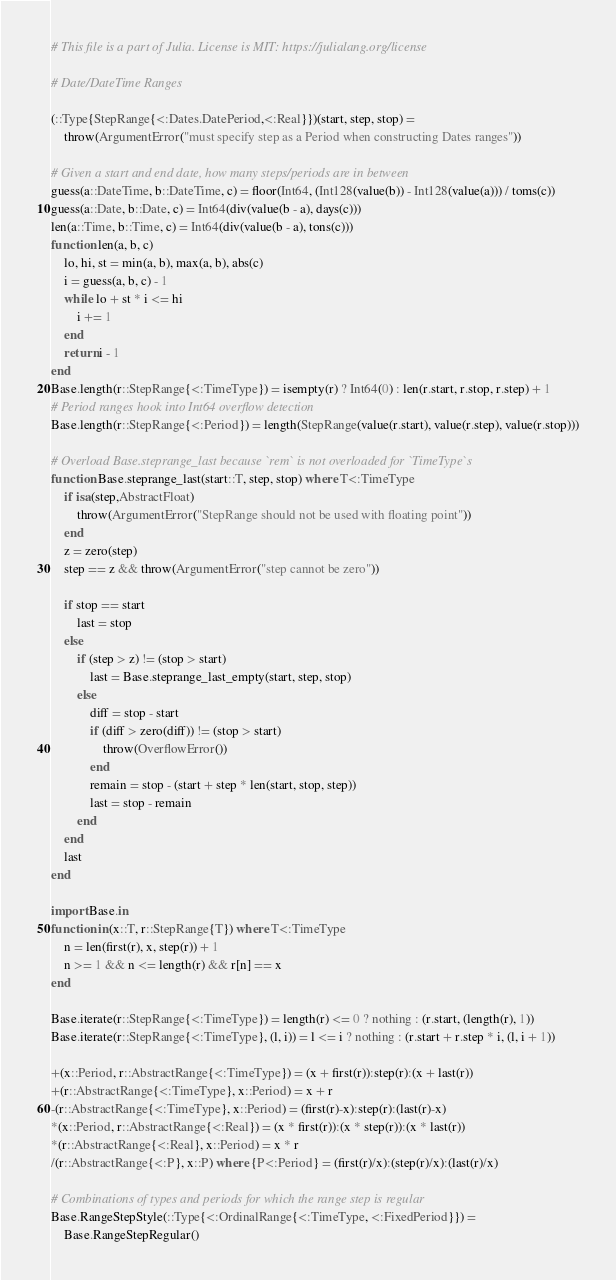<code> <loc_0><loc_0><loc_500><loc_500><_Julia_># This file is a part of Julia. License is MIT: https://julialang.org/license

# Date/DateTime Ranges

(::Type{StepRange{<:Dates.DatePeriod,<:Real}})(start, step, stop) =
    throw(ArgumentError("must specify step as a Period when constructing Dates ranges"))

# Given a start and end date, how many steps/periods are in between
guess(a::DateTime, b::DateTime, c) = floor(Int64, (Int128(value(b)) - Int128(value(a))) / toms(c))
guess(a::Date, b::Date, c) = Int64(div(value(b - a), days(c)))
len(a::Time, b::Time, c) = Int64(div(value(b - a), tons(c)))
function len(a, b, c)
    lo, hi, st = min(a, b), max(a, b), abs(c)
    i = guess(a, b, c) - 1
    while lo + st * i <= hi
        i += 1
    end
    return i - 1
end
Base.length(r::StepRange{<:TimeType}) = isempty(r) ? Int64(0) : len(r.start, r.stop, r.step) + 1
# Period ranges hook into Int64 overflow detection
Base.length(r::StepRange{<:Period}) = length(StepRange(value(r.start), value(r.step), value(r.stop)))

# Overload Base.steprange_last because `rem` is not overloaded for `TimeType`s
function Base.steprange_last(start::T, step, stop) where T<:TimeType
    if isa(step,AbstractFloat)
        throw(ArgumentError("StepRange should not be used with floating point"))
    end
    z = zero(step)
    step == z && throw(ArgumentError("step cannot be zero"))

    if stop == start
        last = stop
    else
        if (step > z) != (stop > start)
            last = Base.steprange_last_empty(start, step, stop)
        else
            diff = stop - start
            if (diff > zero(diff)) != (stop > start)
                throw(OverflowError())
            end
            remain = stop - (start + step * len(start, stop, step))
            last = stop - remain
        end
    end
    last
end

import Base.in
function in(x::T, r::StepRange{T}) where T<:TimeType
    n = len(first(r), x, step(r)) + 1
    n >= 1 && n <= length(r) && r[n] == x
end

Base.iterate(r::StepRange{<:TimeType}) = length(r) <= 0 ? nothing : (r.start, (length(r), 1))
Base.iterate(r::StepRange{<:TimeType}, (l, i)) = l <= i ? nothing : (r.start + r.step * i, (l, i + 1))

+(x::Period, r::AbstractRange{<:TimeType}) = (x + first(r)):step(r):(x + last(r))
+(r::AbstractRange{<:TimeType}, x::Period) = x + r
-(r::AbstractRange{<:TimeType}, x::Period) = (first(r)-x):step(r):(last(r)-x)
*(x::Period, r::AbstractRange{<:Real}) = (x * first(r)):(x * step(r)):(x * last(r))
*(r::AbstractRange{<:Real}, x::Period) = x * r
/(r::AbstractRange{<:P}, x::P) where {P<:Period} = (first(r)/x):(step(r)/x):(last(r)/x)

# Combinations of types and periods for which the range step is regular
Base.RangeStepStyle(::Type{<:OrdinalRange{<:TimeType, <:FixedPeriod}}) =
    Base.RangeStepRegular()
</code> 